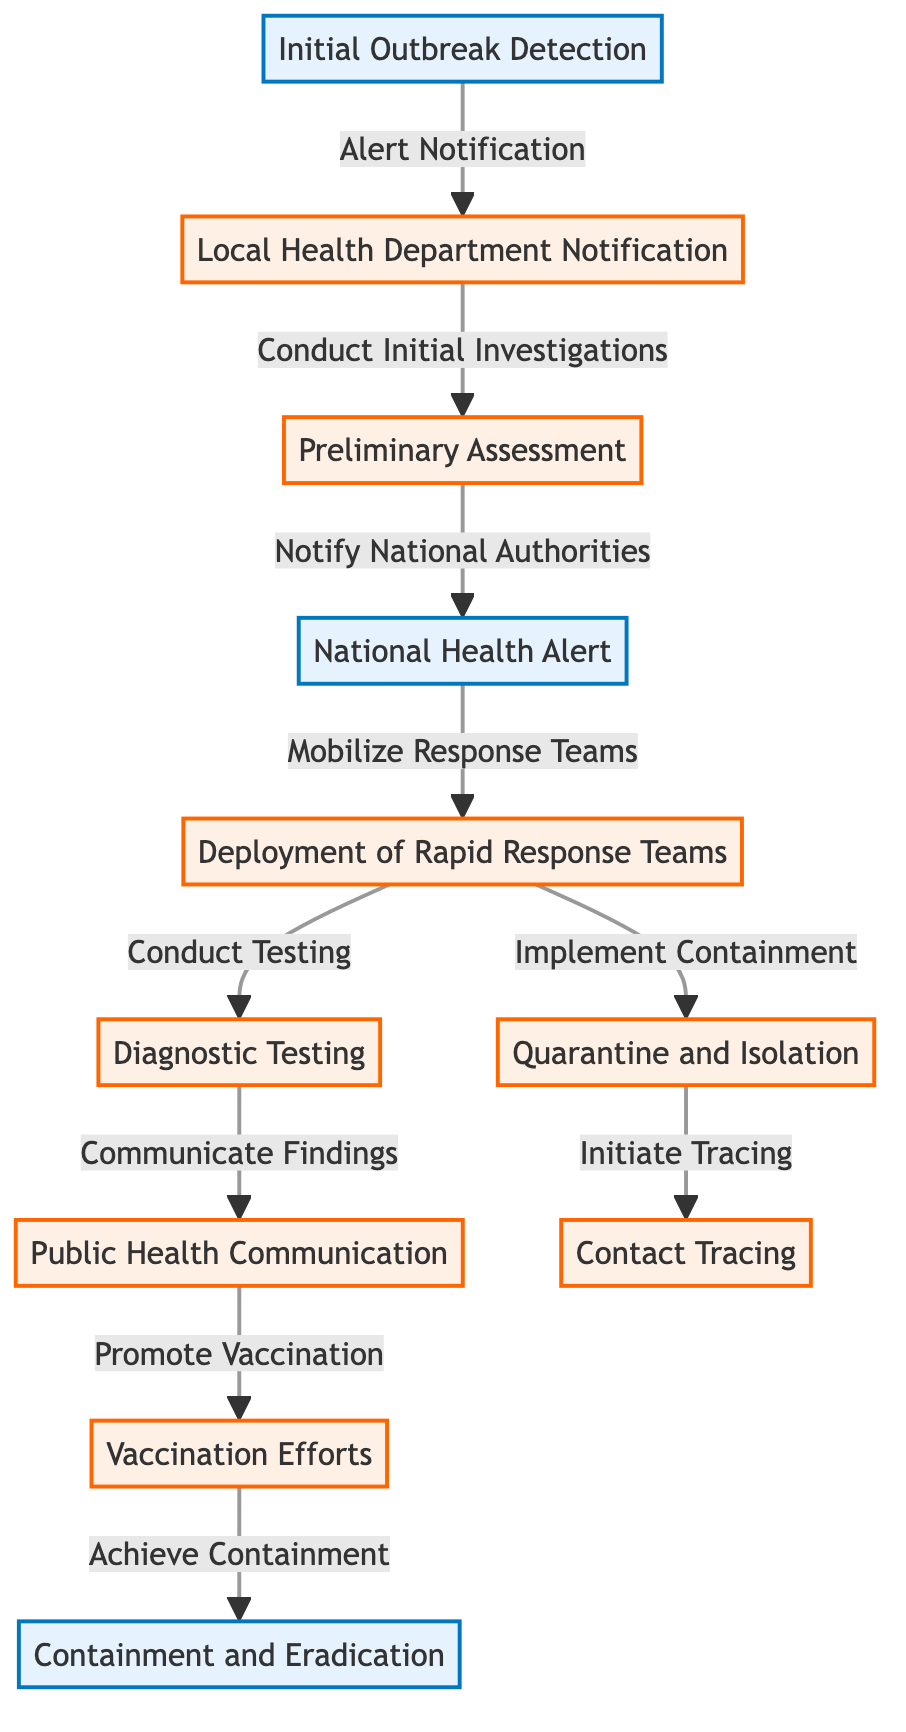What is the first step in the outbreak response? The first step listed in the diagram is "Initial Outbreak Detection." This is the starting point of the response protocol where the outbreak is first identified.
Answer: Initial Outbreak Detection How many major milestones are there in the diagram? The diagram indicates three major milestones: "Initial Outbreak Detection," "National Health Alert," and "Containment and Eradication." These represent significant points in the outbreak response process.
Answer: 3 What action follows "Mobilize Response Teams"? After "Mobilize Response Teams," the next action is "Deployment of Rapid Response Teams." This represents the transition from mobilization to action by deploying teams.
Answer: Deployment of Rapid Response Teams Which step involves public interaction? The step that involves public interaction is "Public Health Communication." This step aims to communicate findings and promote awareness among the public.
Answer: Public Health Communication What occurs concurrently with "Conduct Testing"? Concurrently with "Conduct Testing," the action "Implement Containment" takes place. This indicates that testing and containment measures are implemented simultaneously during the outbreak response.
Answer: Quarantine and Isolation What is the relationship between "Diagnostic Testing" and "Contact Tracing"? "Diagnostic Testing" leads to "Public Health Communication," while "Implement Containment" leads to "Contact Tracing." This means that testing results inform public health communication, and containment efforts necessitate tracing contacts.
Answer: They are sequential steps in the response What is the main goal after "Vaccination Efforts"? The main goal after "Vaccination Efforts" is "Containment and Eradication." This is the final aim of the whole response process after implementing vaccination strategies.
Answer: Containment and Eradication What does the arrow between "Preliminary Assessment" and "National Health Alert" indicate? The arrow indicates a directional flow, showing that "Notify National Authorities" after the "Preliminary Assessment" leads to the issuance of a "National Health Alert." This represents a formal escalation in response protocol.
Answer: Notification flow What color is used for milestone nodes? The milestone nodes are highlighted with a light blue fill and a specific stroke color, which visually distinguishes them from action nodes in the diagram.
Answer: Light blue 